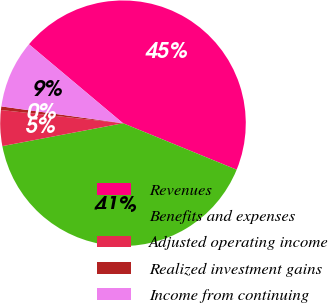Convert chart. <chart><loc_0><loc_0><loc_500><loc_500><pie_chart><fcel>Revenues<fcel>Benefits and expenses<fcel>Adjusted operating income<fcel>Realized investment gains<fcel>Income from continuing<nl><fcel>45.06%<fcel>40.84%<fcel>4.7%<fcel>0.47%<fcel>8.93%<nl></chart> 